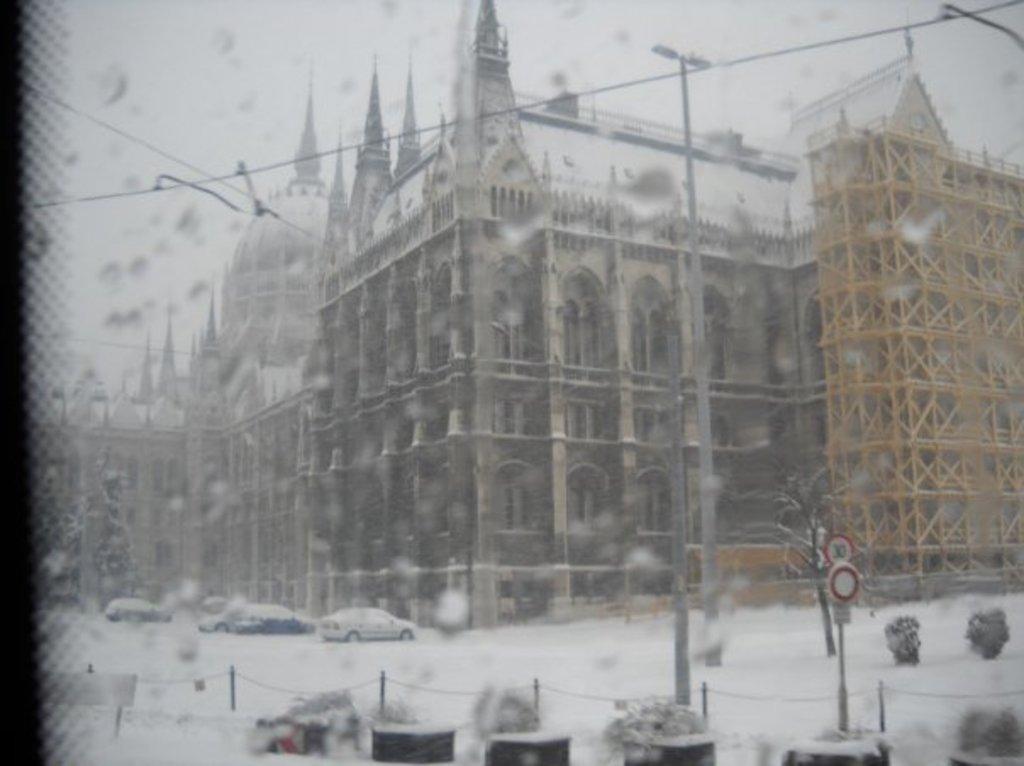In one or two sentences, can you explain what this image depicts? This image looks like a screen. in which we can see the buildings and snow. At the bottom, there are plants and cars covered with the snow. At the top, there is sky. 